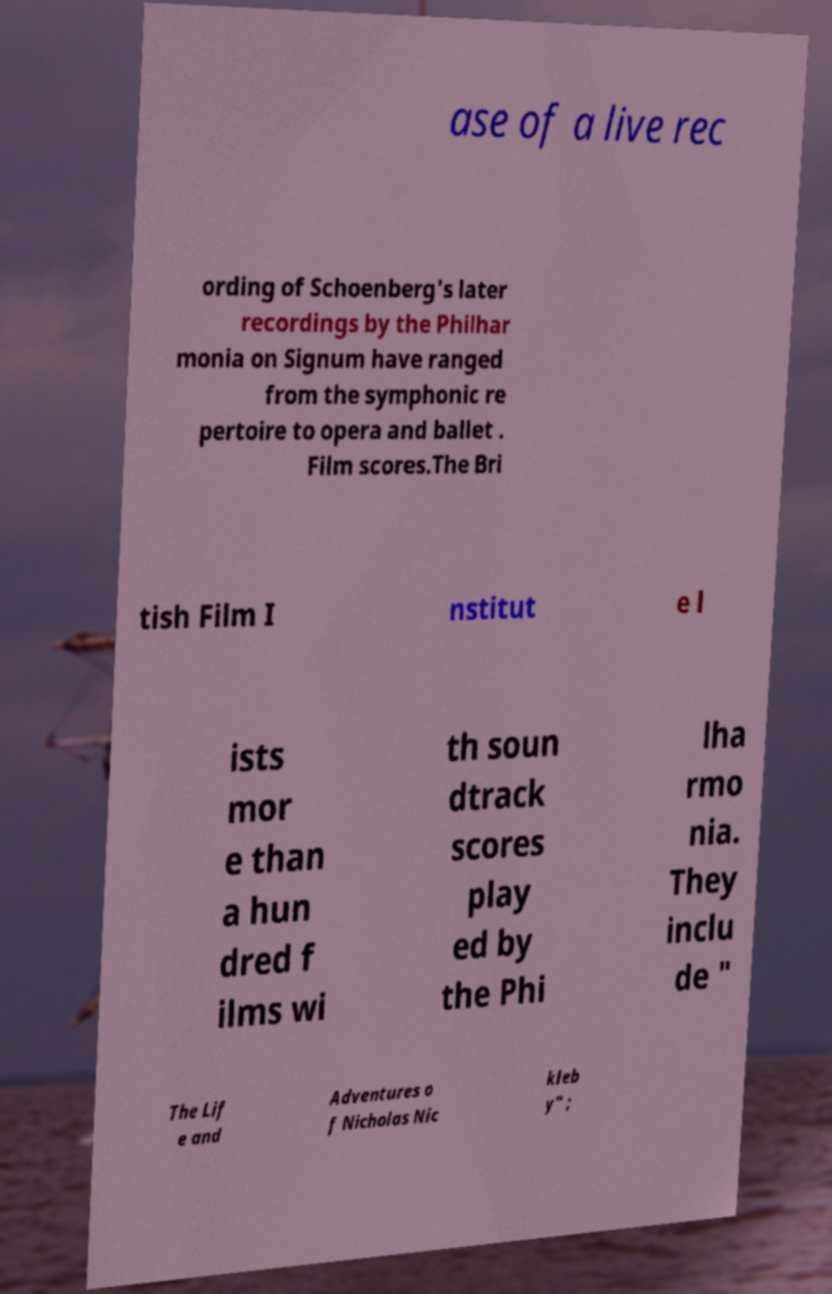There's text embedded in this image that I need extracted. Can you transcribe it verbatim? ase of a live rec ording of Schoenberg's later recordings by the Philhar monia on Signum have ranged from the symphonic re pertoire to opera and ballet . Film scores.The Bri tish Film I nstitut e l ists mor e than a hun dred f ilms wi th soun dtrack scores play ed by the Phi lha rmo nia. They inclu de " The Lif e and Adventures o f Nicholas Nic kleb y" ; 